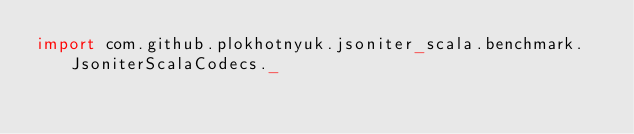Convert code to text. <code><loc_0><loc_0><loc_500><loc_500><_Scala_>import com.github.plokhotnyuk.jsoniter_scala.benchmark.JsoniterScalaCodecs._</code> 